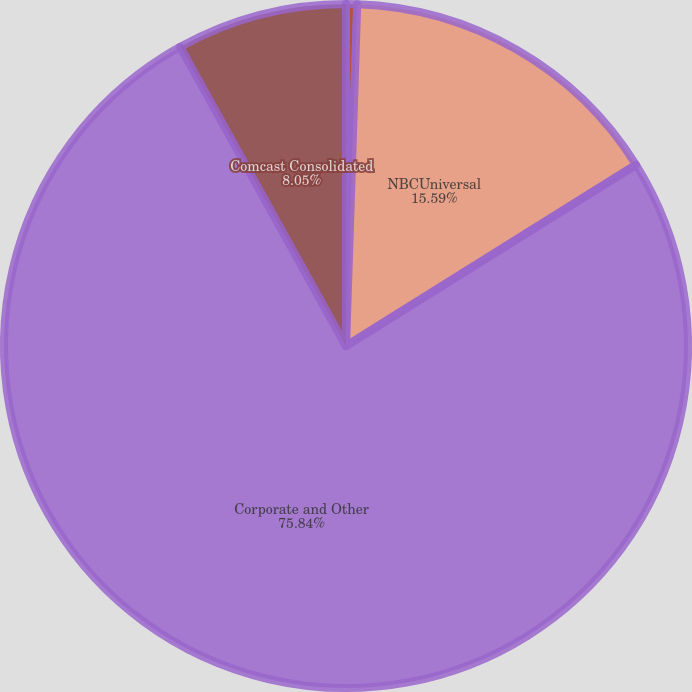Convert chart to OTSL. <chart><loc_0><loc_0><loc_500><loc_500><pie_chart><fcel>Cable Communications<fcel>NBCUniversal<fcel>Corporate and Other<fcel>Comcast Consolidated<nl><fcel>0.52%<fcel>15.59%<fcel>75.84%<fcel>8.05%<nl></chart> 